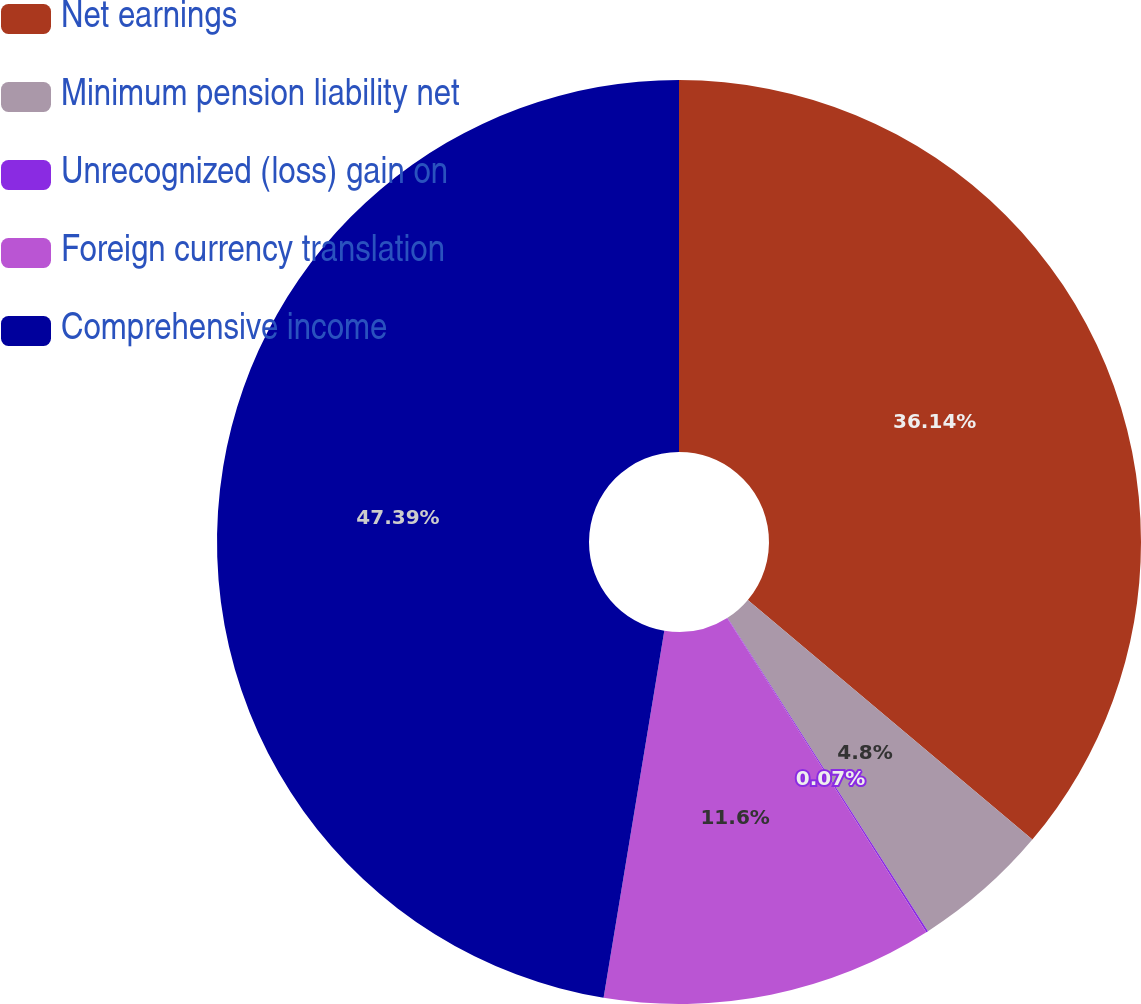Convert chart to OTSL. <chart><loc_0><loc_0><loc_500><loc_500><pie_chart><fcel>Net earnings<fcel>Minimum pension liability net<fcel>Unrecognized (loss) gain on<fcel>Foreign currency translation<fcel>Comprehensive income<nl><fcel>36.14%<fcel>4.8%<fcel>0.07%<fcel>11.6%<fcel>47.39%<nl></chart> 